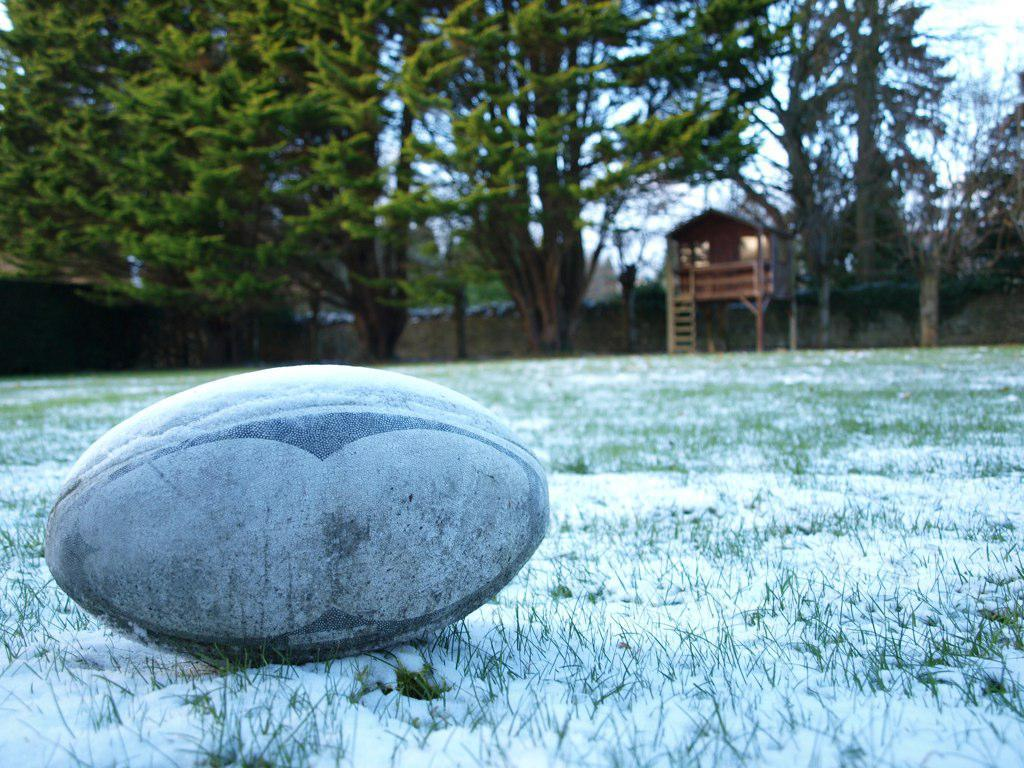What object is on the ground in the image? There is a ball on the ground in the image. What is the condition of the ground in the image? The ground is covered with snow. What type of vegetation can be seen in the image? There are trees visible in the image. What structure is built on the trees in the image? There is a wooden tree house in the image. What type of powder is being used to create the bubbles in the image? There are no bubbles or powder present in the image. How is the butter being used in the image? There is no butter present in the image. 